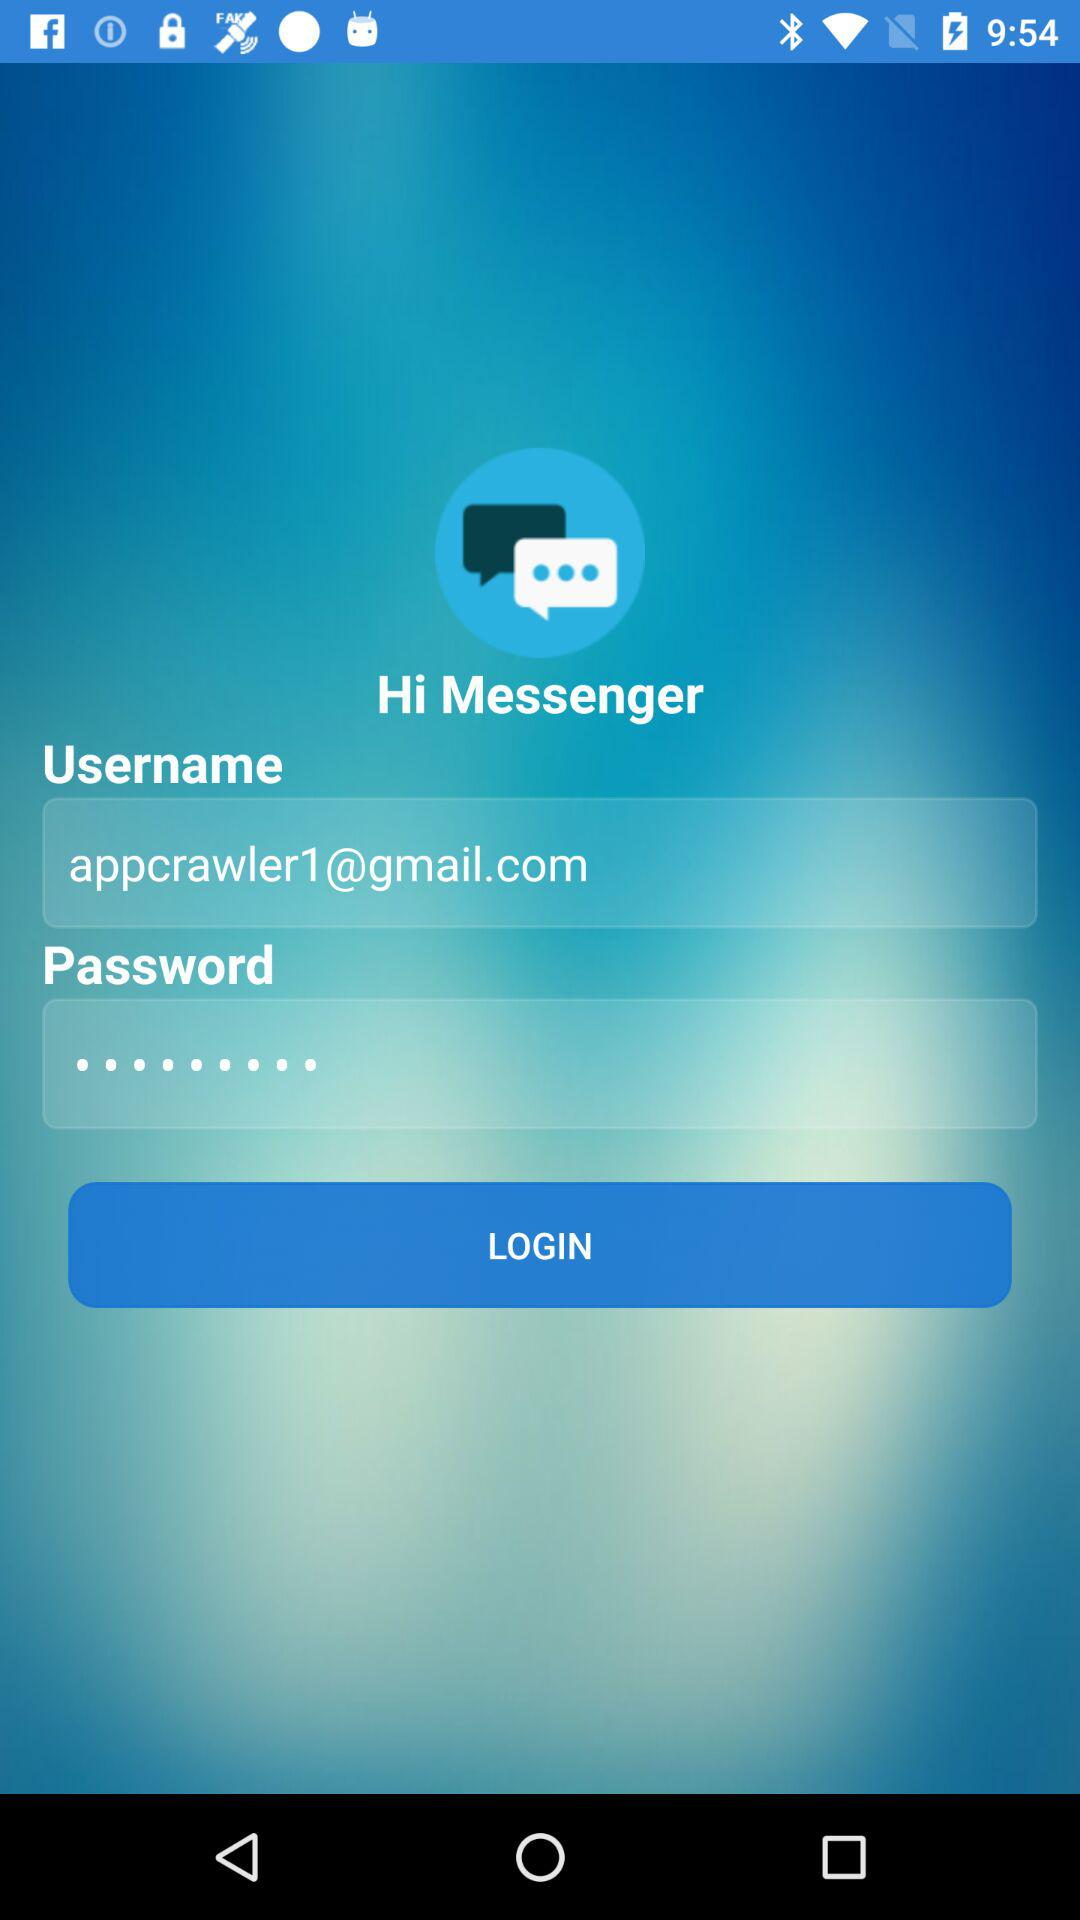How many text fields do you need to fill in to log in?
Answer the question using a single word or phrase. 2 